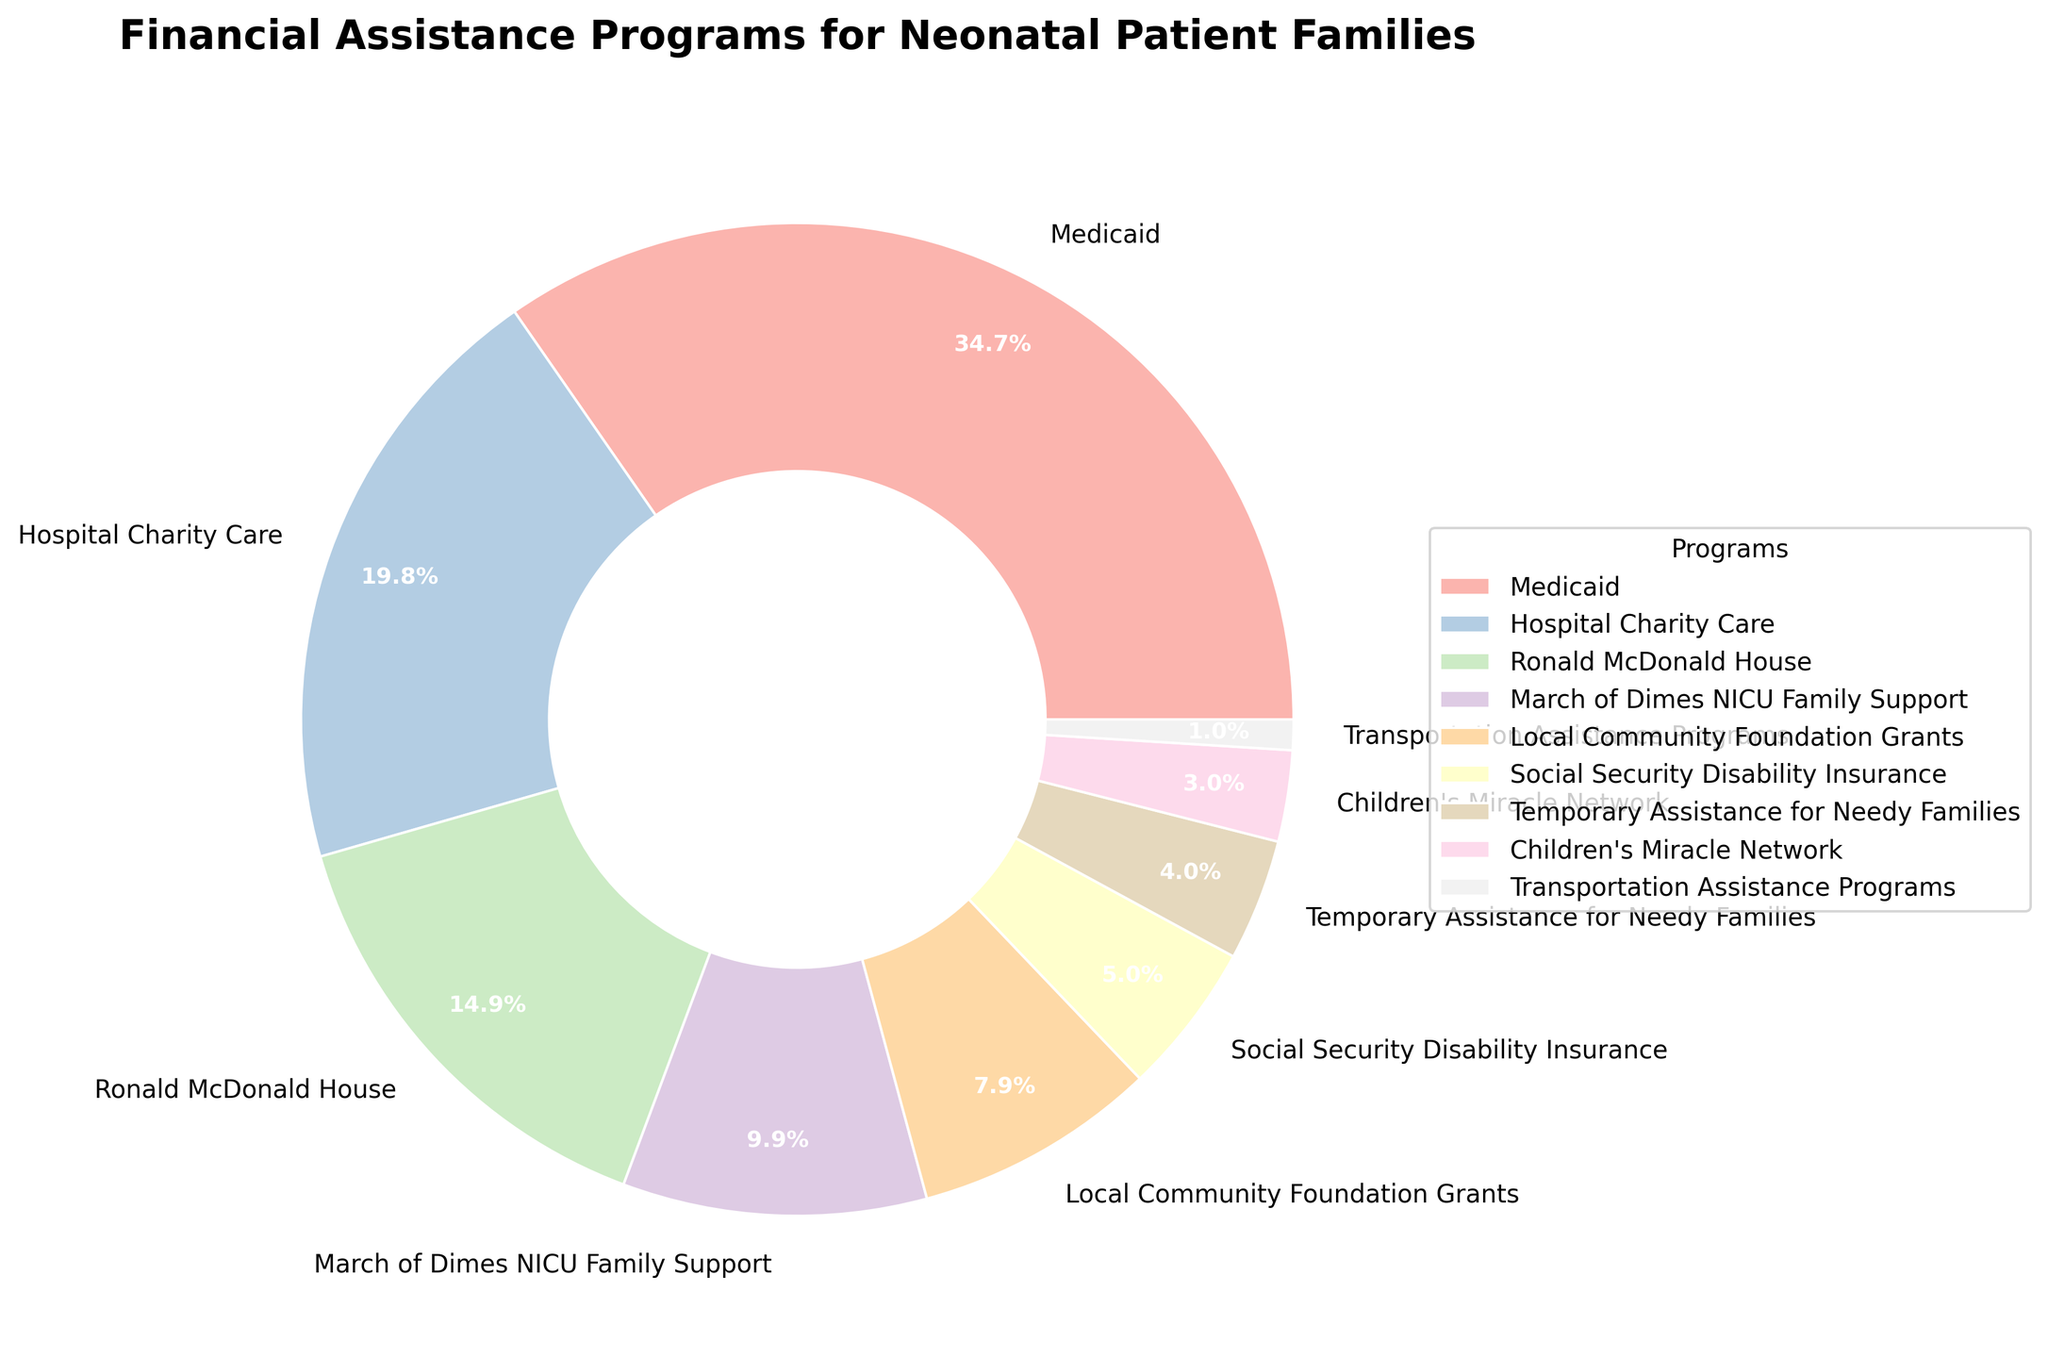Which program provides the highest percentage of financial assistance? The slice representing "Medicaid" is the largest in the pie chart, which indicates it provides the highest percentage of financial assistance.
Answer: Medicaid How much greater is the percentage of Medicaid compared to Hospital Charity Care? Medicaid is 35%, and Hospital Charity Care is 20%. The difference is 35% - 20% = 15%.
Answer: 15% What is the combined percentage of Ronald McDonald House and March of Dimes NICU Family Support? Ronald McDonald House is 15%, and March of Dimes NICU Family Support is 10%. The combined percentage is 15% + 10% = 25%.
Answer: 25% Rank the top three financial assistance programs by percentage. The top three programs based on the largest pie slices are: Medicaid (35%), Hospital Charity Care (20%), Ronald McDonald House (15%).
Answer: Medicaid, Hospital Charity Care, Ronald McDonald House Which programs together make up less than 10% of the assistance provided? The slices representing Social Security Disability Insurance (5%), Temporary Assistance for Needy Families (4%), Children's Miracle Network (3%), and Transportation Assistance Programs (1%) together make up 5% + 4% + 3% + 1% = 13%, which means only Transportation Assistance Programs (1%) is less than 10%.
Answer: Transportation Assistance Programs What percentage of financial assistance is provided by programs other than Medicaid? The total percentage for all programs is 100%. Medicaid is 35%, so other programs provide 100% - 35% = 65%.
Answer: 65% How does the percentage of Local Community Foundation Grants compare to March of Dimes NICU Family Support? Local Community Foundation Grants is 8%, and March of Dimes NICU Family Support is 10%. So, Local Community Foundation Grants is 2% less.
Answer: 2% less What is the percentage difference between Ronald McDonald House and Children's Miracle Network? Ronald McDonald House is 15%, while Children's Miracle Network is 3%. The difference is 15% - 3% = 12%.
Answer: 12% What is the median value of all the financial assistance programs' percentages? The percentages sorted in order are 1%, 3%, 4%, 5%, 8%, 10%, 15%, 20%, 35%. The median value (middle value) is 8%.
Answer: 8% If Transportation Assistance Programs and Children's Miracle Network were combined into one category, what percentage would they represent together? Transportation Assistance Programs is 1% and Children's Miracle Network is 3%. Their combined percentage is 1% + 3% = 4%.
Answer: 4% 